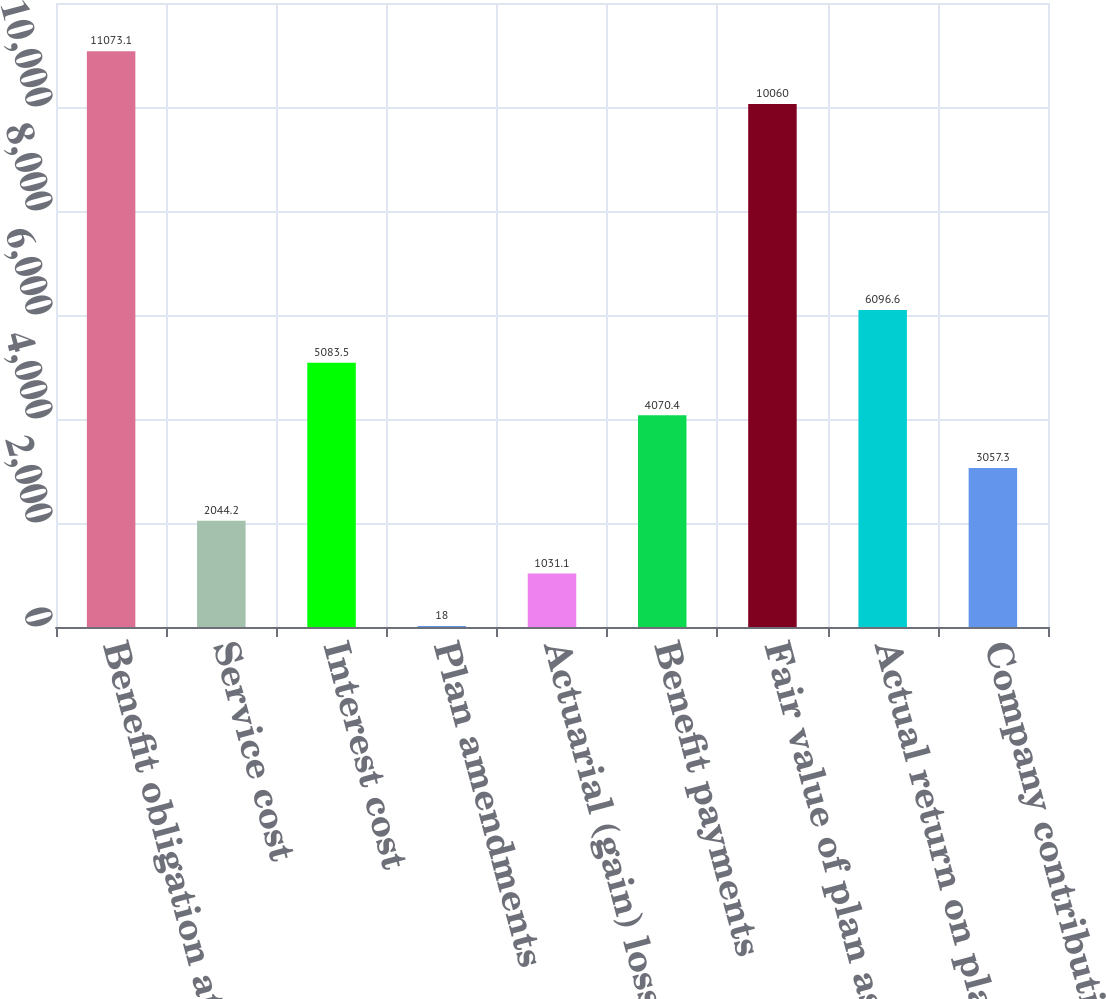Convert chart to OTSL. <chart><loc_0><loc_0><loc_500><loc_500><bar_chart><fcel>Benefit obligation at<fcel>Service cost<fcel>Interest cost<fcel>Plan amendments<fcel>Actuarial (gain) loss<fcel>Benefit payments<fcel>Fair value of plan assets at<fcel>Actual return on plan assets<fcel>Company contributions<nl><fcel>11073.1<fcel>2044.2<fcel>5083.5<fcel>18<fcel>1031.1<fcel>4070.4<fcel>10060<fcel>6096.6<fcel>3057.3<nl></chart> 